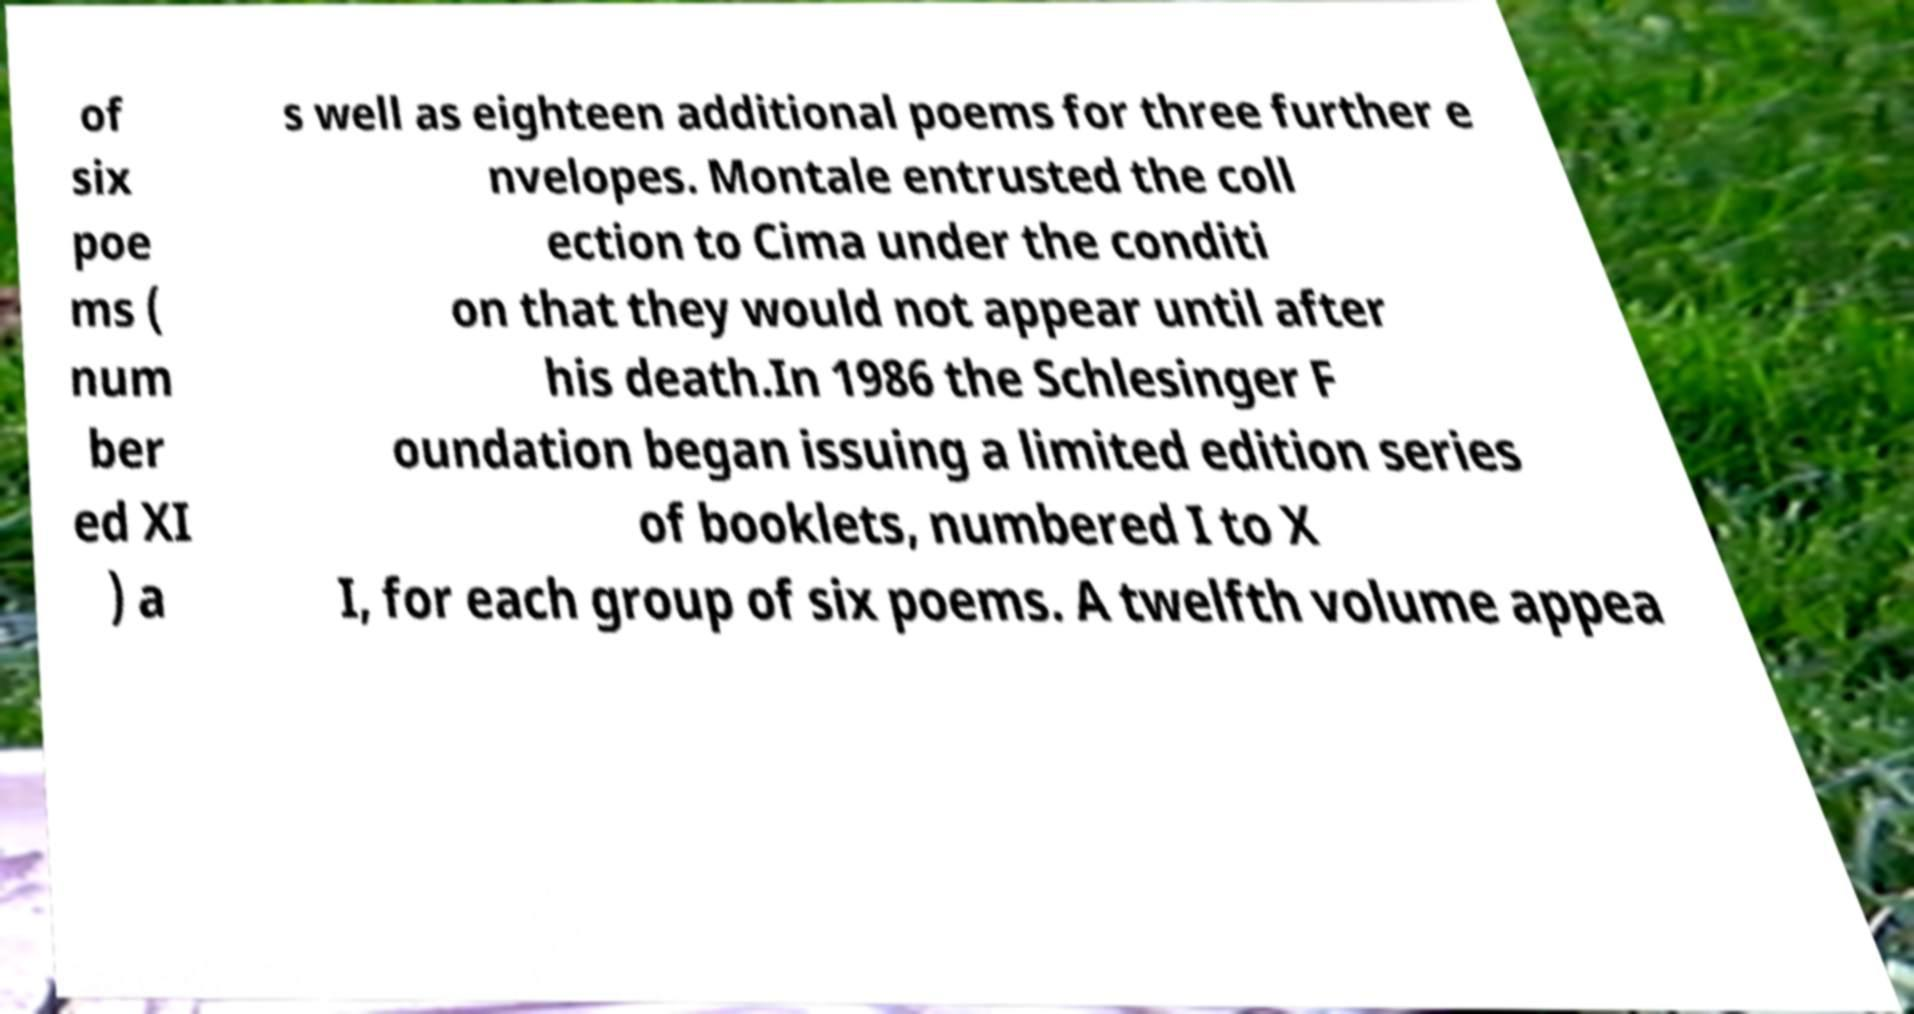Can you read and provide the text displayed in the image?This photo seems to have some interesting text. Can you extract and type it out for me? of six poe ms ( num ber ed XI ) a s well as eighteen additional poems for three further e nvelopes. Montale entrusted the coll ection to Cima under the conditi on that they would not appear until after his death.In 1986 the Schlesinger F oundation began issuing a limited edition series of booklets, numbered I to X I, for each group of six poems. A twelfth volume appea 